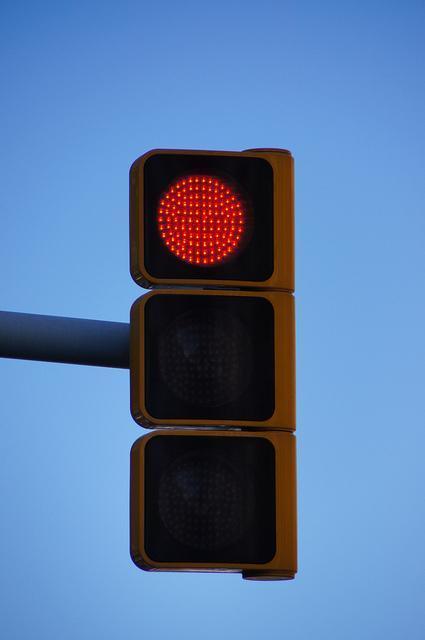How many of the bowls in the image contain mushrooms?
Give a very brief answer. 0. 